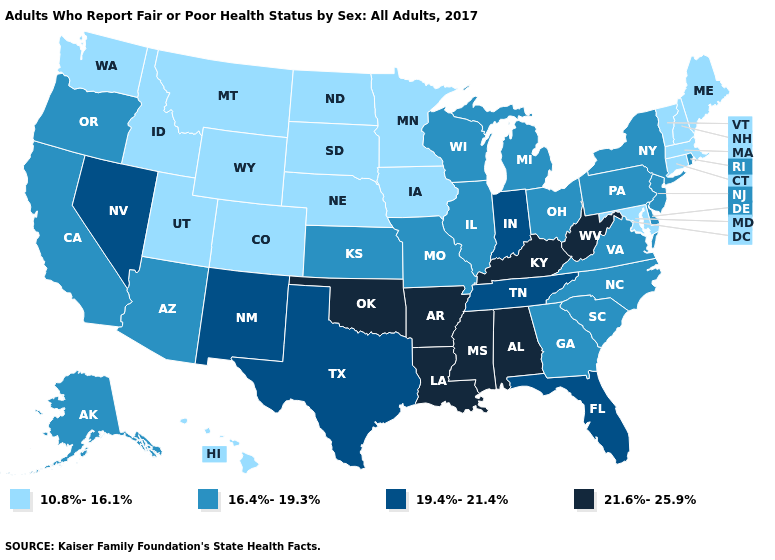Does Louisiana have the highest value in the USA?
Write a very short answer. Yes. Name the states that have a value in the range 16.4%-19.3%?
Be succinct. Alaska, Arizona, California, Delaware, Georgia, Illinois, Kansas, Michigan, Missouri, New Jersey, New York, North Carolina, Ohio, Oregon, Pennsylvania, Rhode Island, South Carolina, Virginia, Wisconsin. Name the states that have a value in the range 19.4%-21.4%?
Give a very brief answer. Florida, Indiana, Nevada, New Mexico, Tennessee, Texas. Does the first symbol in the legend represent the smallest category?
Short answer required. Yes. Name the states that have a value in the range 16.4%-19.3%?
Short answer required. Alaska, Arizona, California, Delaware, Georgia, Illinois, Kansas, Michigan, Missouri, New Jersey, New York, North Carolina, Ohio, Oregon, Pennsylvania, Rhode Island, South Carolina, Virginia, Wisconsin. Does the first symbol in the legend represent the smallest category?
Concise answer only. Yes. What is the lowest value in the MidWest?
Give a very brief answer. 10.8%-16.1%. Which states have the lowest value in the USA?
Write a very short answer. Colorado, Connecticut, Hawaii, Idaho, Iowa, Maine, Maryland, Massachusetts, Minnesota, Montana, Nebraska, New Hampshire, North Dakota, South Dakota, Utah, Vermont, Washington, Wyoming. Does the map have missing data?
Quick response, please. No. Name the states that have a value in the range 16.4%-19.3%?
Quick response, please. Alaska, Arizona, California, Delaware, Georgia, Illinois, Kansas, Michigan, Missouri, New Jersey, New York, North Carolina, Ohio, Oregon, Pennsylvania, Rhode Island, South Carolina, Virginia, Wisconsin. Name the states that have a value in the range 19.4%-21.4%?
Be succinct. Florida, Indiana, Nevada, New Mexico, Tennessee, Texas. Which states have the lowest value in the West?
Write a very short answer. Colorado, Hawaii, Idaho, Montana, Utah, Washington, Wyoming. Among the states that border West Virginia , which have the highest value?
Quick response, please. Kentucky. Name the states that have a value in the range 16.4%-19.3%?
Give a very brief answer. Alaska, Arizona, California, Delaware, Georgia, Illinois, Kansas, Michigan, Missouri, New Jersey, New York, North Carolina, Ohio, Oregon, Pennsylvania, Rhode Island, South Carolina, Virginia, Wisconsin. Does Maine have the highest value in the Northeast?
Quick response, please. No. 